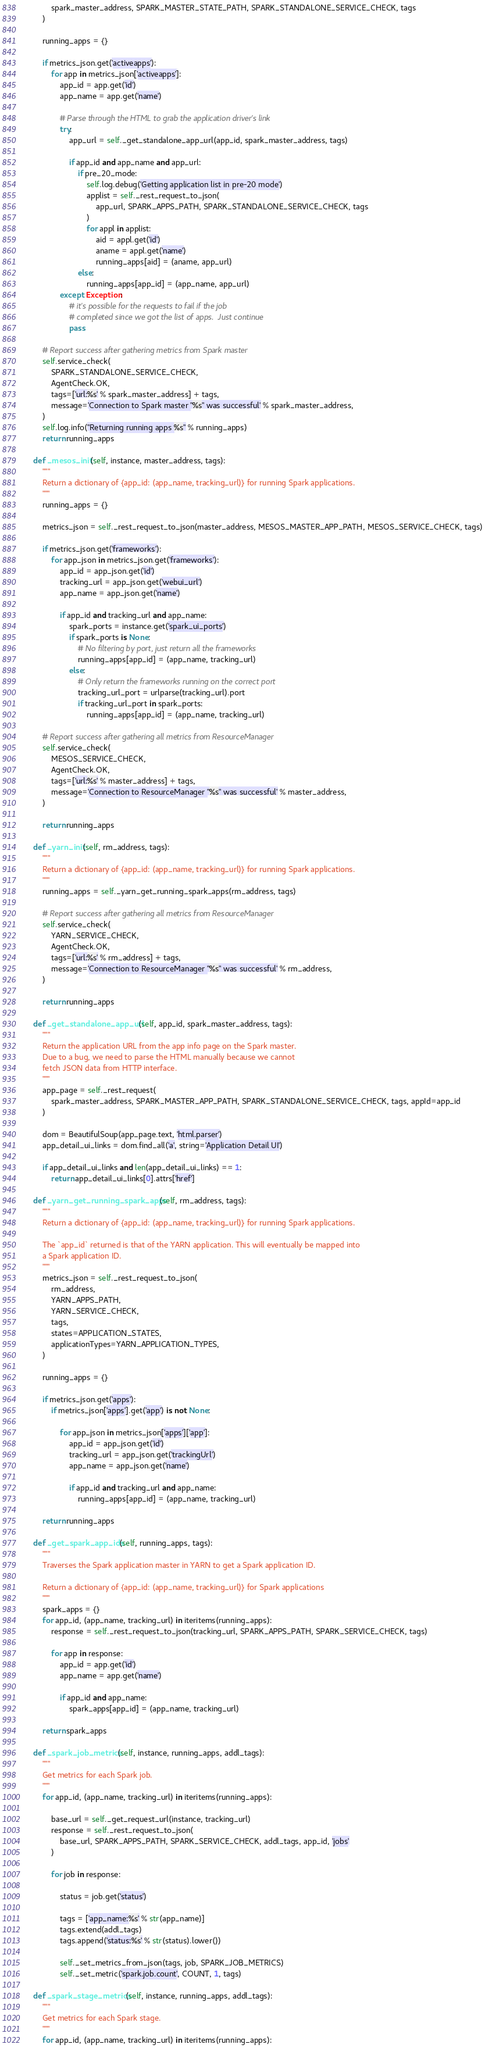Convert code to text. <code><loc_0><loc_0><loc_500><loc_500><_Python_>            spark_master_address, SPARK_MASTER_STATE_PATH, SPARK_STANDALONE_SERVICE_CHECK, tags
        )

        running_apps = {}

        if metrics_json.get('activeapps'):
            for app in metrics_json['activeapps']:
                app_id = app.get('id')
                app_name = app.get('name')

                # Parse through the HTML to grab the application driver's link
                try:
                    app_url = self._get_standalone_app_url(app_id, spark_master_address, tags)

                    if app_id and app_name and app_url:
                        if pre_20_mode:
                            self.log.debug('Getting application list in pre-20 mode')
                            applist = self._rest_request_to_json(
                                app_url, SPARK_APPS_PATH, SPARK_STANDALONE_SERVICE_CHECK, tags
                            )
                            for appl in applist:
                                aid = appl.get('id')
                                aname = appl.get('name')
                                running_apps[aid] = (aname, app_url)
                        else:
                            running_apps[app_id] = (app_name, app_url)
                except Exception:
                    # it's possible for the requests to fail if the job
                    # completed since we got the list of apps.  Just continue
                    pass

        # Report success after gathering metrics from Spark master
        self.service_check(
            SPARK_STANDALONE_SERVICE_CHECK,
            AgentCheck.OK,
            tags=['url:%s' % spark_master_address] + tags,
            message='Connection to Spark master "%s" was successful' % spark_master_address,
        )
        self.log.info("Returning running apps %s" % running_apps)
        return running_apps

    def _mesos_init(self, instance, master_address, tags):
        """
        Return a dictionary of {app_id: (app_name, tracking_url)} for running Spark applications.
        """
        running_apps = {}

        metrics_json = self._rest_request_to_json(master_address, MESOS_MASTER_APP_PATH, MESOS_SERVICE_CHECK, tags)

        if metrics_json.get('frameworks'):
            for app_json in metrics_json.get('frameworks'):
                app_id = app_json.get('id')
                tracking_url = app_json.get('webui_url')
                app_name = app_json.get('name')

                if app_id and tracking_url and app_name:
                    spark_ports = instance.get('spark_ui_ports')
                    if spark_ports is None:
                        # No filtering by port, just return all the frameworks
                        running_apps[app_id] = (app_name, tracking_url)
                    else:
                        # Only return the frameworks running on the correct port
                        tracking_url_port = urlparse(tracking_url).port
                        if tracking_url_port in spark_ports:
                            running_apps[app_id] = (app_name, tracking_url)

        # Report success after gathering all metrics from ResourceManager
        self.service_check(
            MESOS_SERVICE_CHECK,
            AgentCheck.OK,
            tags=['url:%s' % master_address] + tags,
            message='Connection to ResourceManager "%s" was successful' % master_address,
        )

        return running_apps

    def _yarn_init(self, rm_address, tags):
        """
        Return a dictionary of {app_id: (app_name, tracking_url)} for running Spark applications.
        """
        running_apps = self._yarn_get_running_spark_apps(rm_address, tags)

        # Report success after gathering all metrics from ResourceManager
        self.service_check(
            YARN_SERVICE_CHECK,
            AgentCheck.OK,
            tags=['url:%s' % rm_address] + tags,
            message='Connection to ResourceManager "%s" was successful' % rm_address,
        )

        return running_apps

    def _get_standalone_app_url(self, app_id, spark_master_address, tags):
        """
        Return the application URL from the app info page on the Spark master.
        Due to a bug, we need to parse the HTML manually because we cannot
        fetch JSON data from HTTP interface.
        """
        app_page = self._rest_request(
            spark_master_address, SPARK_MASTER_APP_PATH, SPARK_STANDALONE_SERVICE_CHECK, tags, appId=app_id
        )

        dom = BeautifulSoup(app_page.text, 'html.parser')
        app_detail_ui_links = dom.find_all('a', string='Application Detail UI')

        if app_detail_ui_links and len(app_detail_ui_links) == 1:
            return app_detail_ui_links[0].attrs['href']

    def _yarn_get_running_spark_apps(self, rm_address, tags):
        """
        Return a dictionary of {app_id: (app_name, tracking_url)} for running Spark applications.

        The `app_id` returned is that of the YARN application. This will eventually be mapped into
        a Spark application ID.
        """
        metrics_json = self._rest_request_to_json(
            rm_address,
            YARN_APPS_PATH,
            YARN_SERVICE_CHECK,
            tags,
            states=APPLICATION_STATES,
            applicationTypes=YARN_APPLICATION_TYPES,
        )

        running_apps = {}

        if metrics_json.get('apps'):
            if metrics_json['apps'].get('app') is not None:

                for app_json in metrics_json['apps']['app']:
                    app_id = app_json.get('id')
                    tracking_url = app_json.get('trackingUrl')
                    app_name = app_json.get('name')

                    if app_id and tracking_url and app_name:
                        running_apps[app_id] = (app_name, tracking_url)

        return running_apps

    def _get_spark_app_ids(self, running_apps, tags):
        """
        Traverses the Spark application master in YARN to get a Spark application ID.

        Return a dictionary of {app_id: (app_name, tracking_url)} for Spark applications
        """
        spark_apps = {}
        for app_id, (app_name, tracking_url) in iteritems(running_apps):
            response = self._rest_request_to_json(tracking_url, SPARK_APPS_PATH, SPARK_SERVICE_CHECK, tags)

            for app in response:
                app_id = app.get('id')
                app_name = app.get('name')

                if app_id and app_name:
                    spark_apps[app_id] = (app_name, tracking_url)

        return spark_apps

    def _spark_job_metrics(self, instance, running_apps, addl_tags):
        """
        Get metrics for each Spark job.
        """
        for app_id, (app_name, tracking_url) in iteritems(running_apps):

            base_url = self._get_request_url(instance, tracking_url)
            response = self._rest_request_to_json(
                base_url, SPARK_APPS_PATH, SPARK_SERVICE_CHECK, addl_tags, app_id, 'jobs'
            )

            for job in response:

                status = job.get('status')

                tags = ['app_name:%s' % str(app_name)]
                tags.extend(addl_tags)
                tags.append('status:%s' % str(status).lower())

                self._set_metrics_from_json(tags, job, SPARK_JOB_METRICS)
                self._set_metric('spark.job.count', COUNT, 1, tags)

    def _spark_stage_metrics(self, instance, running_apps, addl_tags):
        """
        Get metrics for each Spark stage.
        """
        for app_id, (app_name, tracking_url) in iteritems(running_apps):
</code> 